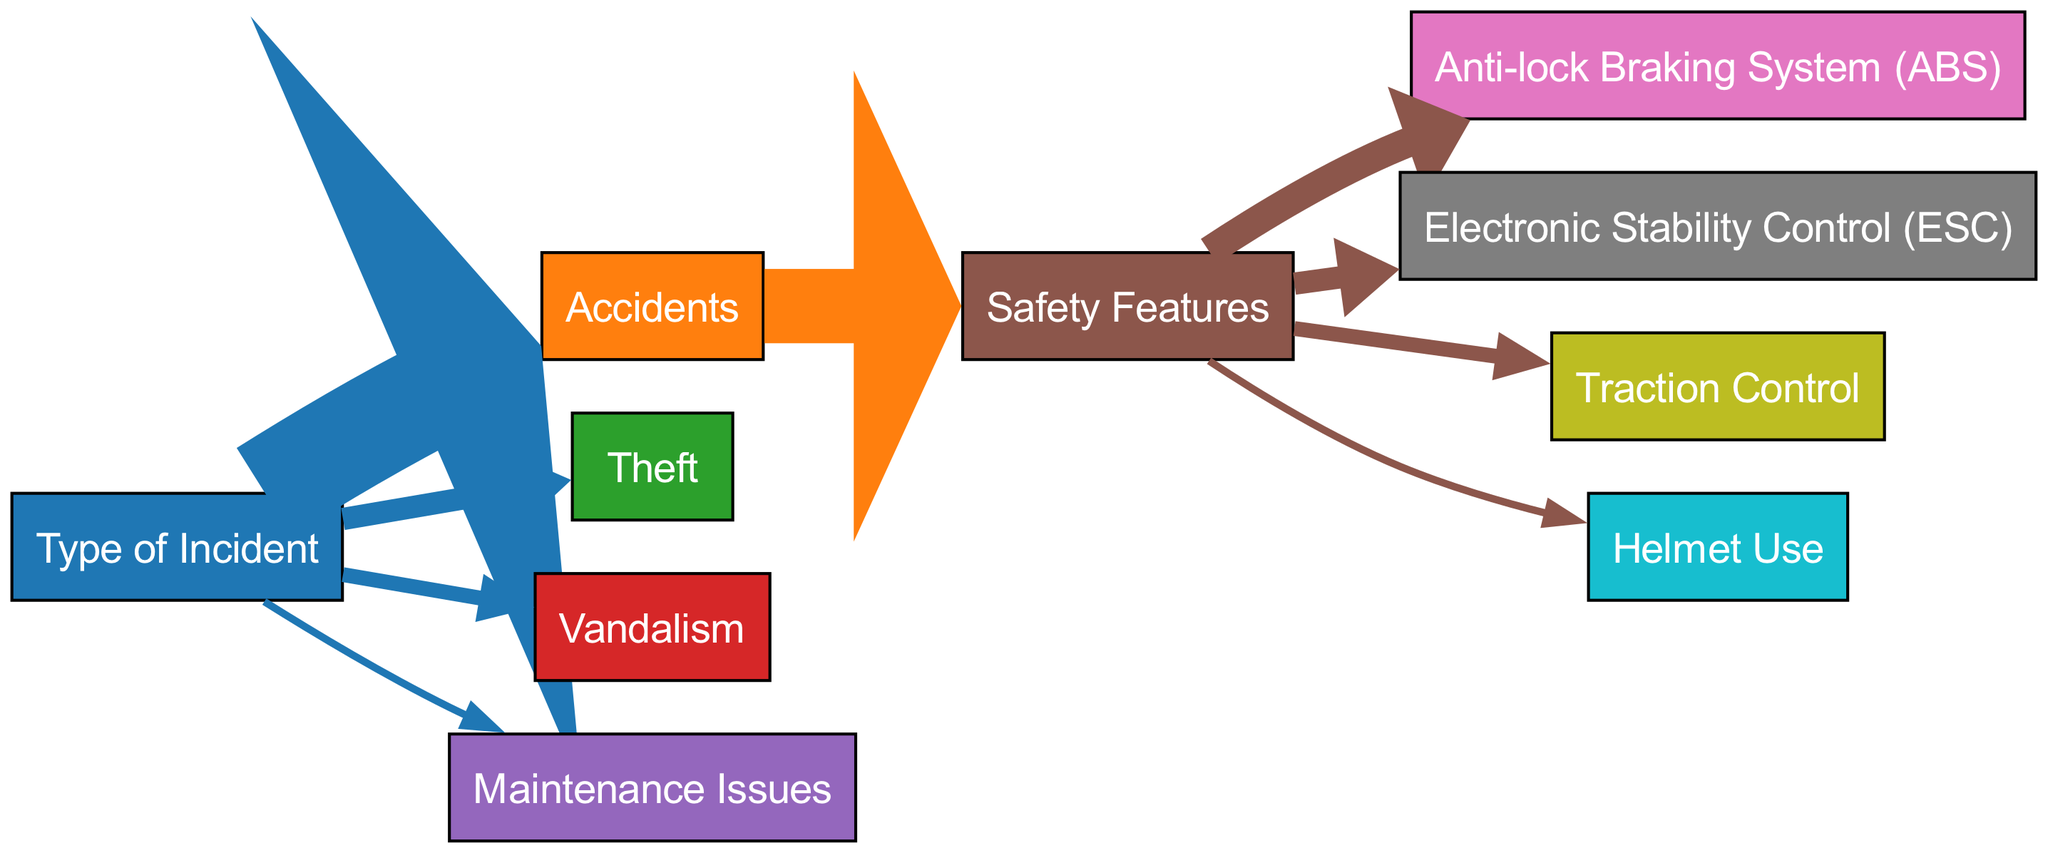What is the total number of incidents represented in the diagram? The total number of incidents can be calculated by summing the values of each incident type: Accidents (70), Theft (15), Vandalism (10), and Maintenance Issues (5). Adding these values together gives 70 + 15 + 10 + 5 = 100.
Answer: 100 What type of incident has the highest value? By examining the diagram, we can see that the node "Accidents" has the highest value of 70 compared to the other incident types (Theft, Vandalism, and Maintenance Issues).
Answer: Accidents What proportion of incidents are related to Theft? The value for Theft is 15 out of a total of 100 incidents. To find the proportion, we calculate 15/100 = 0.15 or 15%.
Answer: 15% What is the value for the Anti-lock Braking System? The diagram shows a direct relationship between "Safety Features" and "Anti-lock Braking System," with a value of 20 indicating the number of claims related to this safety feature.
Answer: 20 Which safety feature is least represented in terms of incidents? Looking at the "Safety Features" node and its linked edges, we find that "Helmet Use" has the least value of 5 among the safety features listed (ABS, ESC, Traction Control).
Answer: Helmet Use How many safety features are associated with the Accidents type? The "Safety Features" node connects to four different features: Anti-lock Braking System, Electronic Stability Control, Traction Control, and Helmet Use. Therefore, there are four safety features associated with accidents.
Answer: 4 What percentage of accidents are associated with Safety Features? The value for accidents is 70, and the value associated with safety features is 50. To find the percentage, we calculate (50/70)*100, which gives approximately 71.43%.
Answer: 71.43% Which type of incident has no direct safety feature connection? Upon examining the diagram, "Theft," "Vandalism," and "Maintenance Issues" do not have any edges leading to or from the "Safety Features" node. Thus, they do not connect with safety features at all, meaning they have no direct safety feature connection.
Answer: Theft, Vandalism, Maintenance Issues What could be inferred about the relationship between accidents and safety features? The diagram indicates that a significant portion (50 out of 70 accidents) is related to the presence of safety features, illustrating their impact on reducing the severity or occurrence of accidents in motorcycles.
Answer: Safety features significantly impact accidents 